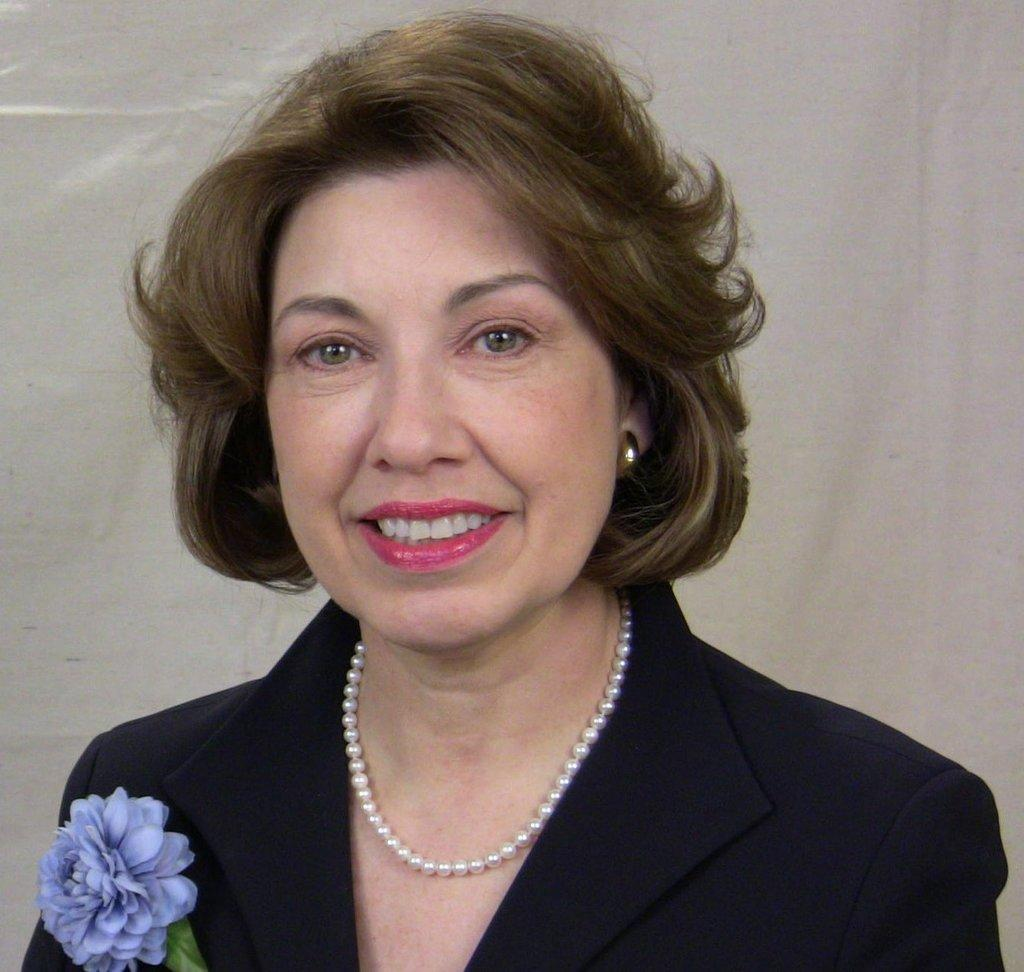What is the main subject of the image? The main subject of the image is a woman. What is the woman wearing in the image? The woman is wearing a black dress in the image. What other object can be seen in the image? There is a flower in the image. Where is the park located in the image? There is no park present in the image. What type of flower is being pushed by the woman in the image? There is no flower being pushed by the woman in the image, as the woman is not interacting with any flowers. 